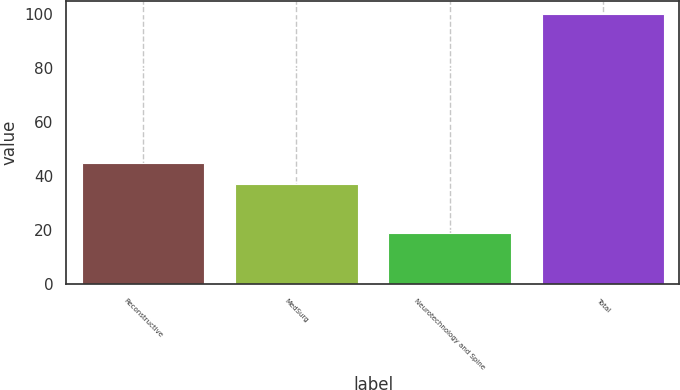<chart> <loc_0><loc_0><loc_500><loc_500><bar_chart><fcel>Reconstructive<fcel>MedSurg<fcel>Neurotechnology and Spine<fcel>Total<nl><fcel>45.1<fcel>37<fcel>19<fcel>100<nl></chart> 